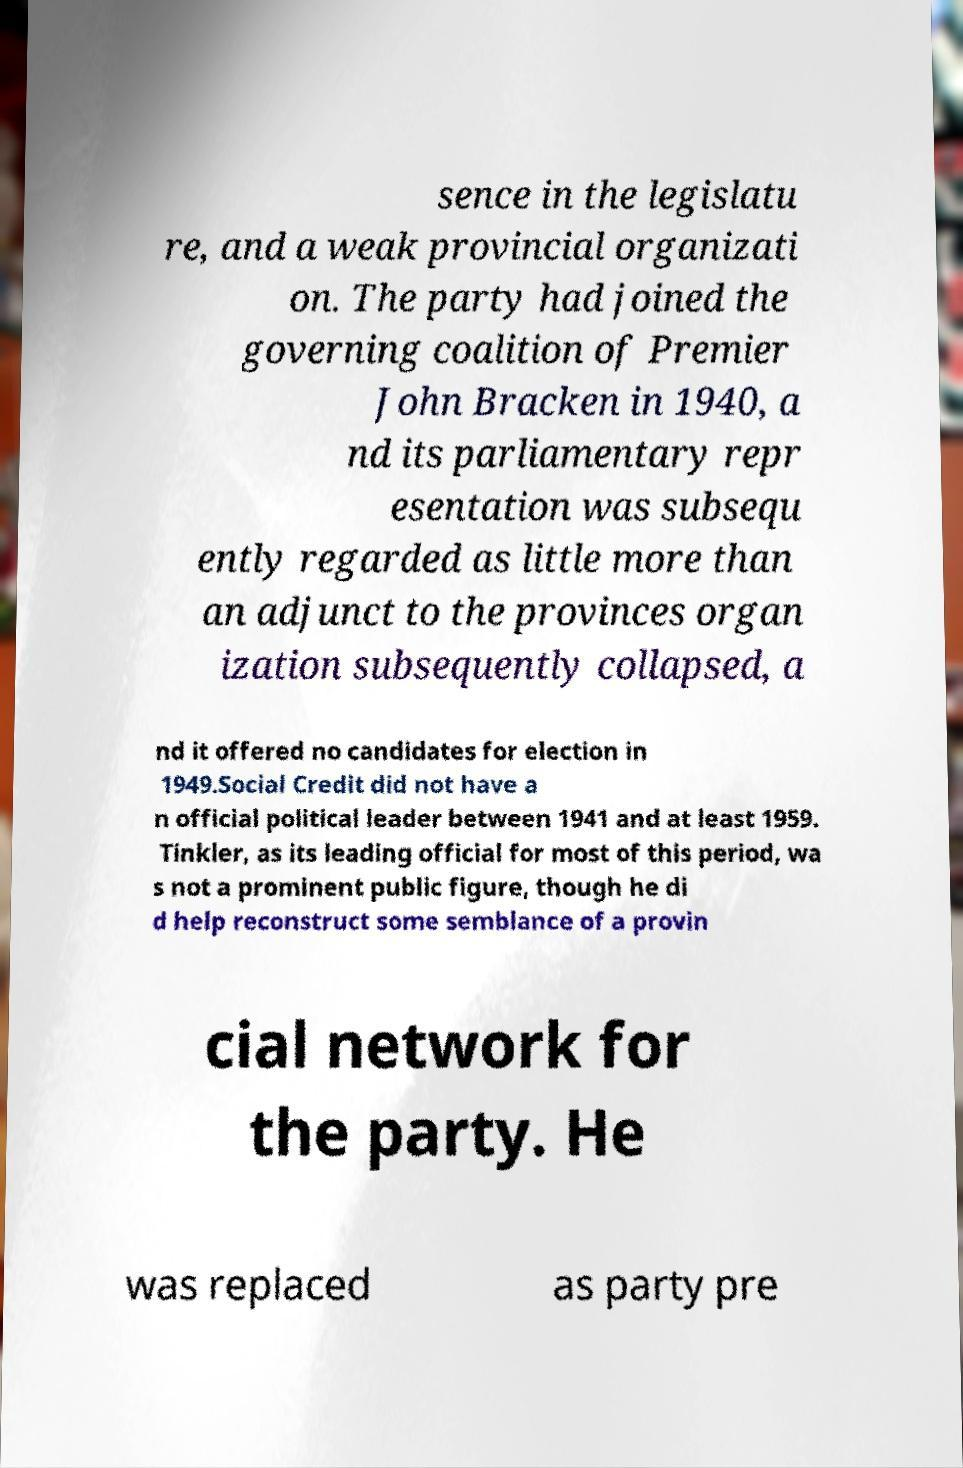Can you accurately transcribe the text from the provided image for me? sence in the legislatu re, and a weak provincial organizati on. The party had joined the governing coalition of Premier John Bracken in 1940, a nd its parliamentary repr esentation was subsequ ently regarded as little more than an adjunct to the provinces organ ization subsequently collapsed, a nd it offered no candidates for election in 1949.Social Credit did not have a n official political leader between 1941 and at least 1959. Tinkler, as its leading official for most of this period, wa s not a prominent public figure, though he di d help reconstruct some semblance of a provin cial network for the party. He was replaced as party pre 